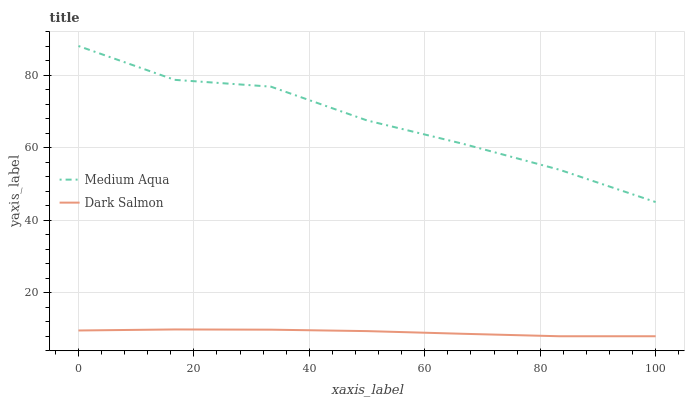Does Dark Salmon have the maximum area under the curve?
Answer yes or no. No. Is Dark Salmon the roughest?
Answer yes or no. No. Does Dark Salmon have the highest value?
Answer yes or no. No. Is Dark Salmon less than Medium Aqua?
Answer yes or no. Yes. Is Medium Aqua greater than Dark Salmon?
Answer yes or no. Yes. Does Dark Salmon intersect Medium Aqua?
Answer yes or no. No. 